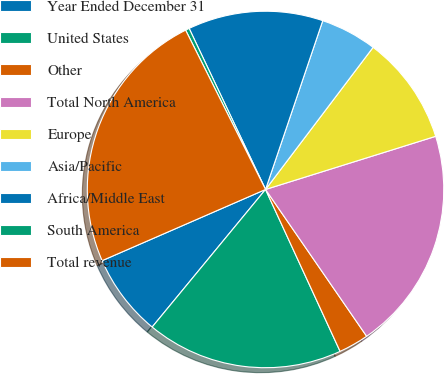<chart> <loc_0><loc_0><loc_500><loc_500><pie_chart><fcel>Year Ended December 31<fcel>United States<fcel>Other<fcel>Total North America<fcel>Europe<fcel>Asia/Pacific<fcel>Africa/Middle East<fcel>South America<fcel>Total revenue<nl><fcel>7.49%<fcel>17.84%<fcel>2.73%<fcel>20.22%<fcel>9.87%<fcel>5.11%<fcel>12.25%<fcel>0.35%<fcel>24.14%<nl></chart> 